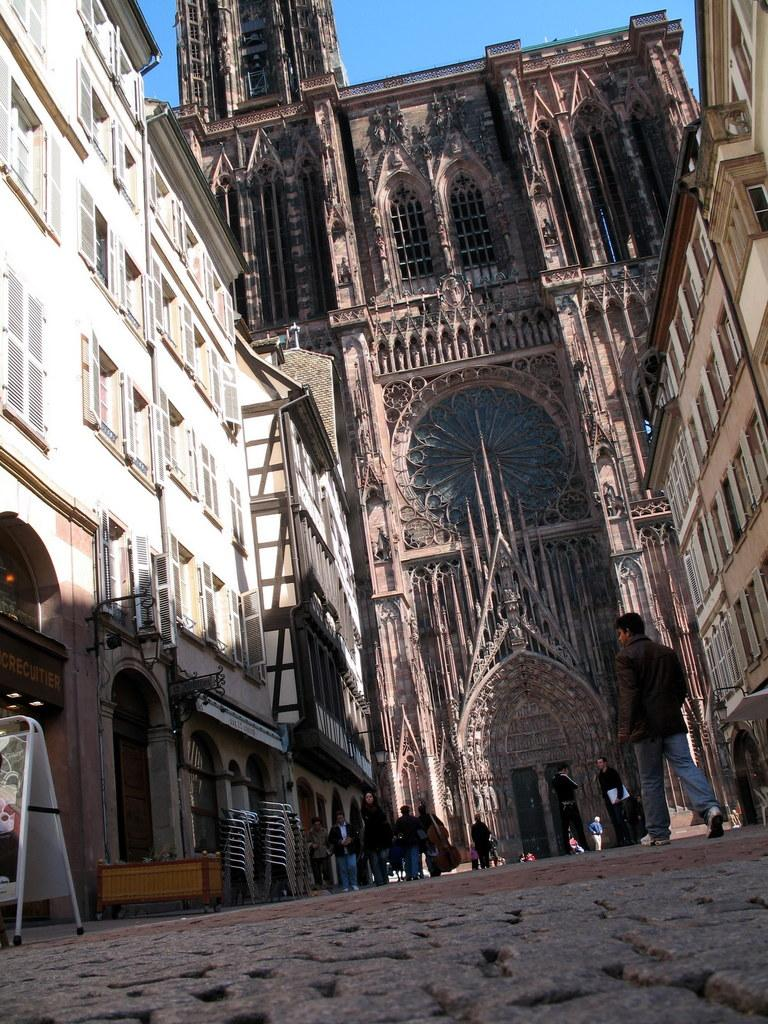How many people are in the image? There is a group of people in the image, but the exact number is not specified. What are the people in the image doing? The people are walking on the ground in the image. What type of furniture is present in the image? There are chairs and a table in the image. What musical instrument can be seen in the image? A violin is present in the image. What type of surface is the board placed on in the image? The board is placed on a surface that is not specified in the image. What type of buildings can be seen in the image? There are buildings with windows in the image. What is visible in the background of the image? The sky is visible in the background of the image. What type of wool is being used to make the lizards' clothing in the image? There are no lizards or clothing visible in the image. What month is it in the image? The month is not specified in the image. 